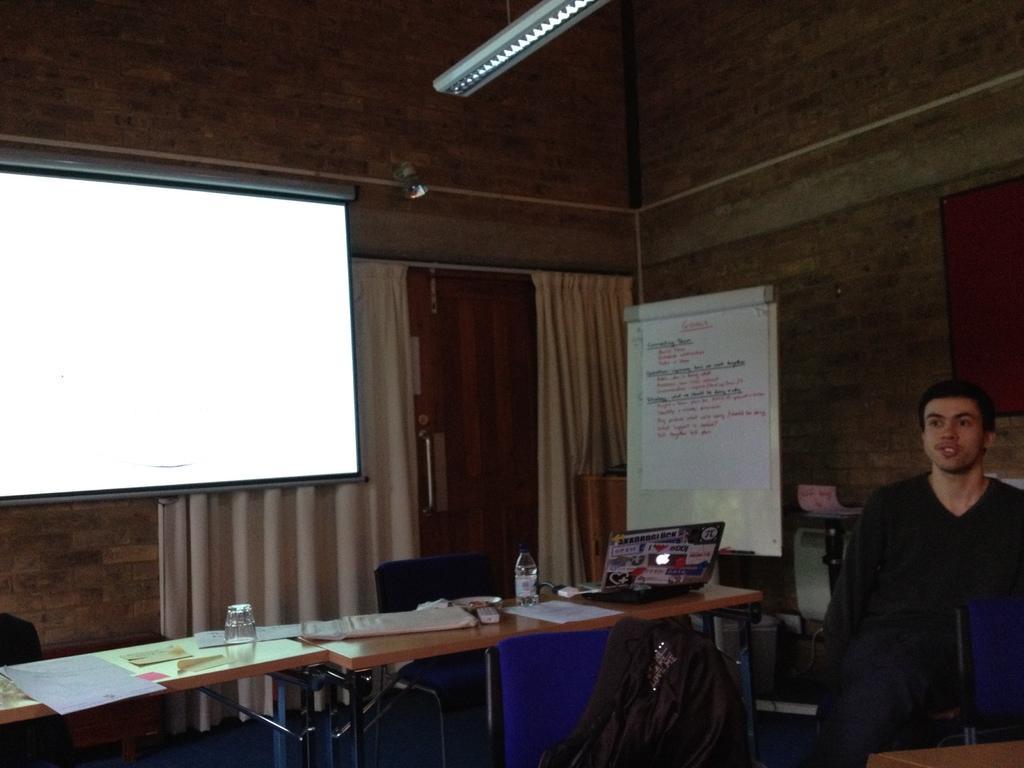How would you summarize this image in a sentence or two? In the foreground I can see tables, laptop, bottles, papers, chairs and a person on the floor. In the background I can see a screen, board, curtains, wall, some objects and light on a rooftop. This image is taken may be in a hall. 